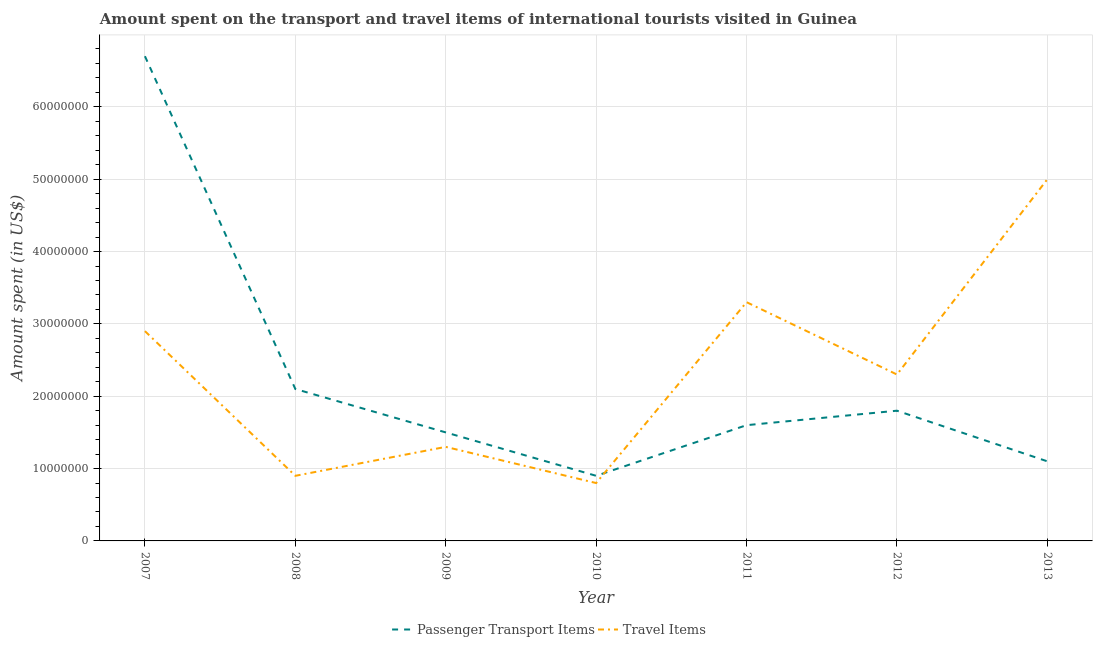How many different coloured lines are there?
Your response must be concise. 2. What is the amount spent on passenger transport items in 2008?
Your response must be concise. 2.10e+07. Across all years, what is the maximum amount spent in travel items?
Give a very brief answer. 5.00e+07. Across all years, what is the minimum amount spent on passenger transport items?
Offer a very short reply. 9.00e+06. In which year was the amount spent in travel items maximum?
Provide a short and direct response. 2013. What is the total amount spent on passenger transport items in the graph?
Make the answer very short. 1.57e+08. What is the difference between the amount spent on passenger transport items in 2008 and that in 2009?
Your answer should be very brief. 6.00e+06. What is the difference between the amount spent on passenger transport items in 2007 and the amount spent in travel items in 2011?
Give a very brief answer. 3.40e+07. What is the average amount spent on passenger transport items per year?
Provide a short and direct response. 2.24e+07. In the year 2009, what is the difference between the amount spent on passenger transport items and amount spent in travel items?
Your answer should be compact. 2.00e+06. In how many years, is the amount spent on passenger transport items greater than 28000000 US$?
Your answer should be compact. 1. What is the ratio of the amount spent in travel items in 2008 to that in 2011?
Offer a terse response. 0.27. Is the amount spent in travel items in 2009 less than that in 2010?
Offer a very short reply. No. Is the difference between the amount spent in travel items in 2010 and 2011 greater than the difference between the amount spent on passenger transport items in 2010 and 2011?
Give a very brief answer. No. What is the difference between the highest and the second highest amount spent on passenger transport items?
Your answer should be very brief. 4.60e+07. What is the difference between the highest and the lowest amount spent in travel items?
Provide a succinct answer. 4.20e+07. In how many years, is the amount spent on passenger transport items greater than the average amount spent on passenger transport items taken over all years?
Provide a succinct answer. 1. Is the sum of the amount spent in travel items in 2010 and 2012 greater than the maximum amount spent on passenger transport items across all years?
Keep it short and to the point. No. Is the amount spent in travel items strictly less than the amount spent on passenger transport items over the years?
Offer a terse response. No. How many lines are there?
Your answer should be very brief. 2. How many years are there in the graph?
Provide a succinct answer. 7. What is the difference between two consecutive major ticks on the Y-axis?
Give a very brief answer. 1.00e+07. Are the values on the major ticks of Y-axis written in scientific E-notation?
Ensure brevity in your answer.  No. Does the graph contain any zero values?
Offer a very short reply. No. Where does the legend appear in the graph?
Your answer should be compact. Bottom center. How many legend labels are there?
Provide a succinct answer. 2. What is the title of the graph?
Give a very brief answer. Amount spent on the transport and travel items of international tourists visited in Guinea. Does "Foreign Liabilities" appear as one of the legend labels in the graph?
Offer a terse response. No. What is the label or title of the Y-axis?
Keep it short and to the point. Amount spent (in US$). What is the Amount spent (in US$) in Passenger Transport Items in 2007?
Ensure brevity in your answer.  6.70e+07. What is the Amount spent (in US$) of Travel Items in 2007?
Offer a very short reply. 2.90e+07. What is the Amount spent (in US$) in Passenger Transport Items in 2008?
Provide a succinct answer. 2.10e+07. What is the Amount spent (in US$) in Travel Items in 2008?
Your answer should be compact. 9.00e+06. What is the Amount spent (in US$) of Passenger Transport Items in 2009?
Provide a succinct answer. 1.50e+07. What is the Amount spent (in US$) of Travel Items in 2009?
Your answer should be very brief. 1.30e+07. What is the Amount spent (in US$) of Passenger Transport Items in 2010?
Your response must be concise. 9.00e+06. What is the Amount spent (in US$) of Passenger Transport Items in 2011?
Your response must be concise. 1.60e+07. What is the Amount spent (in US$) in Travel Items in 2011?
Provide a short and direct response. 3.30e+07. What is the Amount spent (in US$) of Passenger Transport Items in 2012?
Your answer should be compact. 1.80e+07. What is the Amount spent (in US$) of Travel Items in 2012?
Your response must be concise. 2.30e+07. What is the Amount spent (in US$) of Passenger Transport Items in 2013?
Provide a succinct answer. 1.10e+07. What is the Amount spent (in US$) of Travel Items in 2013?
Make the answer very short. 5.00e+07. Across all years, what is the maximum Amount spent (in US$) of Passenger Transport Items?
Your response must be concise. 6.70e+07. Across all years, what is the minimum Amount spent (in US$) of Passenger Transport Items?
Provide a short and direct response. 9.00e+06. Across all years, what is the minimum Amount spent (in US$) in Travel Items?
Your answer should be compact. 8.00e+06. What is the total Amount spent (in US$) of Passenger Transport Items in the graph?
Offer a very short reply. 1.57e+08. What is the total Amount spent (in US$) of Travel Items in the graph?
Offer a terse response. 1.65e+08. What is the difference between the Amount spent (in US$) of Passenger Transport Items in 2007 and that in 2008?
Provide a succinct answer. 4.60e+07. What is the difference between the Amount spent (in US$) of Passenger Transport Items in 2007 and that in 2009?
Your answer should be compact. 5.20e+07. What is the difference between the Amount spent (in US$) in Travel Items in 2007 and that in 2009?
Make the answer very short. 1.60e+07. What is the difference between the Amount spent (in US$) in Passenger Transport Items in 2007 and that in 2010?
Offer a terse response. 5.80e+07. What is the difference between the Amount spent (in US$) in Travel Items in 2007 and that in 2010?
Your answer should be compact. 2.10e+07. What is the difference between the Amount spent (in US$) of Passenger Transport Items in 2007 and that in 2011?
Ensure brevity in your answer.  5.10e+07. What is the difference between the Amount spent (in US$) of Passenger Transport Items in 2007 and that in 2012?
Keep it short and to the point. 4.90e+07. What is the difference between the Amount spent (in US$) of Passenger Transport Items in 2007 and that in 2013?
Give a very brief answer. 5.60e+07. What is the difference between the Amount spent (in US$) in Travel Items in 2007 and that in 2013?
Provide a succinct answer. -2.10e+07. What is the difference between the Amount spent (in US$) in Passenger Transport Items in 2008 and that in 2011?
Make the answer very short. 5.00e+06. What is the difference between the Amount spent (in US$) of Travel Items in 2008 and that in 2011?
Your answer should be very brief. -2.40e+07. What is the difference between the Amount spent (in US$) of Travel Items in 2008 and that in 2012?
Your response must be concise. -1.40e+07. What is the difference between the Amount spent (in US$) in Passenger Transport Items in 2008 and that in 2013?
Your answer should be compact. 1.00e+07. What is the difference between the Amount spent (in US$) of Travel Items in 2008 and that in 2013?
Give a very brief answer. -4.10e+07. What is the difference between the Amount spent (in US$) of Travel Items in 2009 and that in 2011?
Provide a succinct answer. -2.00e+07. What is the difference between the Amount spent (in US$) of Passenger Transport Items in 2009 and that in 2012?
Make the answer very short. -3.00e+06. What is the difference between the Amount spent (in US$) in Travel Items in 2009 and that in 2012?
Your answer should be very brief. -1.00e+07. What is the difference between the Amount spent (in US$) in Travel Items in 2009 and that in 2013?
Give a very brief answer. -3.70e+07. What is the difference between the Amount spent (in US$) in Passenger Transport Items in 2010 and that in 2011?
Offer a terse response. -7.00e+06. What is the difference between the Amount spent (in US$) of Travel Items in 2010 and that in 2011?
Make the answer very short. -2.50e+07. What is the difference between the Amount spent (in US$) in Passenger Transport Items in 2010 and that in 2012?
Ensure brevity in your answer.  -9.00e+06. What is the difference between the Amount spent (in US$) in Travel Items in 2010 and that in 2012?
Your answer should be compact. -1.50e+07. What is the difference between the Amount spent (in US$) of Travel Items in 2010 and that in 2013?
Provide a succinct answer. -4.20e+07. What is the difference between the Amount spent (in US$) of Passenger Transport Items in 2011 and that in 2012?
Provide a succinct answer. -2.00e+06. What is the difference between the Amount spent (in US$) of Passenger Transport Items in 2011 and that in 2013?
Ensure brevity in your answer.  5.00e+06. What is the difference between the Amount spent (in US$) of Travel Items in 2011 and that in 2013?
Offer a terse response. -1.70e+07. What is the difference between the Amount spent (in US$) in Passenger Transport Items in 2012 and that in 2013?
Your answer should be very brief. 7.00e+06. What is the difference between the Amount spent (in US$) in Travel Items in 2012 and that in 2013?
Your answer should be compact. -2.70e+07. What is the difference between the Amount spent (in US$) of Passenger Transport Items in 2007 and the Amount spent (in US$) of Travel Items in 2008?
Offer a very short reply. 5.80e+07. What is the difference between the Amount spent (in US$) of Passenger Transport Items in 2007 and the Amount spent (in US$) of Travel Items in 2009?
Your response must be concise. 5.40e+07. What is the difference between the Amount spent (in US$) of Passenger Transport Items in 2007 and the Amount spent (in US$) of Travel Items in 2010?
Make the answer very short. 5.90e+07. What is the difference between the Amount spent (in US$) in Passenger Transport Items in 2007 and the Amount spent (in US$) in Travel Items in 2011?
Your answer should be very brief. 3.40e+07. What is the difference between the Amount spent (in US$) of Passenger Transport Items in 2007 and the Amount spent (in US$) of Travel Items in 2012?
Ensure brevity in your answer.  4.40e+07. What is the difference between the Amount spent (in US$) in Passenger Transport Items in 2007 and the Amount spent (in US$) in Travel Items in 2013?
Your answer should be very brief. 1.70e+07. What is the difference between the Amount spent (in US$) of Passenger Transport Items in 2008 and the Amount spent (in US$) of Travel Items in 2009?
Offer a terse response. 8.00e+06. What is the difference between the Amount spent (in US$) in Passenger Transport Items in 2008 and the Amount spent (in US$) in Travel Items in 2010?
Make the answer very short. 1.30e+07. What is the difference between the Amount spent (in US$) in Passenger Transport Items in 2008 and the Amount spent (in US$) in Travel Items in 2011?
Provide a short and direct response. -1.20e+07. What is the difference between the Amount spent (in US$) of Passenger Transport Items in 2008 and the Amount spent (in US$) of Travel Items in 2012?
Offer a terse response. -2.00e+06. What is the difference between the Amount spent (in US$) in Passenger Transport Items in 2008 and the Amount spent (in US$) in Travel Items in 2013?
Offer a terse response. -2.90e+07. What is the difference between the Amount spent (in US$) in Passenger Transport Items in 2009 and the Amount spent (in US$) in Travel Items in 2010?
Offer a very short reply. 7.00e+06. What is the difference between the Amount spent (in US$) in Passenger Transport Items in 2009 and the Amount spent (in US$) in Travel Items in 2011?
Your answer should be compact. -1.80e+07. What is the difference between the Amount spent (in US$) in Passenger Transport Items in 2009 and the Amount spent (in US$) in Travel Items in 2012?
Offer a terse response. -8.00e+06. What is the difference between the Amount spent (in US$) of Passenger Transport Items in 2009 and the Amount spent (in US$) of Travel Items in 2013?
Provide a succinct answer. -3.50e+07. What is the difference between the Amount spent (in US$) of Passenger Transport Items in 2010 and the Amount spent (in US$) of Travel Items in 2011?
Ensure brevity in your answer.  -2.40e+07. What is the difference between the Amount spent (in US$) of Passenger Transport Items in 2010 and the Amount spent (in US$) of Travel Items in 2012?
Keep it short and to the point. -1.40e+07. What is the difference between the Amount spent (in US$) of Passenger Transport Items in 2010 and the Amount spent (in US$) of Travel Items in 2013?
Provide a succinct answer. -4.10e+07. What is the difference between the Amount spent (in US$) in Passenger Transport Items in 2011 and the Amount spent (in US$) in Travel Items in 2012?
Offer a very short reply. -7.00e+06. What is the difference between the Amount spent (in US$) of Passenger Transport Items in 2011 and the Amount spent (in US$) of Travel Items in 2013?
Your answer should be very brief. -3.40e+07. What is the difference between the Amount spent (in US$) of Passenger Transport Items in 2012 and the Amount spent (in US$) of Travel Items in 2013?
Your answer should be compact. -3.20e+07. What is the average Amount spent (in US$) of Passenger Transport Items per year?
Your answer should be compact. 2.24e+07. What is the average Amount spent (in US$) in Travel Items per year?
Offer a very short reply. 2.36e+07. In the year 2007, what is the difference between the Amount spent (in US$) in Passenger Transport Items and Amount spent (in US$) in Travel Items?
Offer a very short reply. 3.80e+07. In the year 2010, what is the difference between the Amount spent (in US$) in Passenger Transport Items and Amount spent (in US$) in Travel Items?
Give a very brief answer. 1.00e+06. In the year 2011, what is the difference between the Amount spent (in US$) in Passenger Transport Items and Amount spent (in US$) in Travel Items?
Your answer should be very brief. -1.70e+07. In the year 2012, what is the difference between the Amount spent (in US$) of Passenger Transport Items and Amount spent (in US$) of Travel Items?
Keep it short and to the point. -5.00e+06. In the year 2013, what is the difference between the Amount spent (in US$) in Passenger Transport Items and Amount spent (in US$) in Travel Items?
Make the answer very short. -3.90e+07. What is the ratio of the Amount spent (in US$) of Passenger Transport Items in 2007 to that in 2008?
Offer a terse response. 3.19. What is the ratio of the Amount spent (in US$) in Travel Items in 2007 to that in 2008?
Make the answer very short. 3.22. What is the ratio of the Amount spent (in US$) in Passenger Transport Items in 2007 to that in 2009?
Your answer should be compact. 4.47. What is the ratio of the Amount spent (in US$) in Travel Items in 2007 to that in 2009?
Your answer should be very brief. 2.23. What is the ratio of the Amount spent (in US$) in Passenger Transport Items in 2007 to that in 2010?
Your response must be concise. 7.44. What is the ratio of the Amount spent (in US$) in Travel Items in 2007 to that in 2010?
Keep it short and to the point. 3.62. What is the ratio of the Amount spent (in US$) of Passenger Transport Items in 2007 to that in 2011?
Keep it short and to the point. 4.19. What is the ratio of the Amount spent (in US$) in Travel Items in 2007 to that in 2011?
Provide a short and direct response. 0.88. What is the ratio of the Amount spent (in US$) of Passenger Transport Items in 2007 to that in 2012?
Ensure brevity in your answer.  3.72. What is the ratio of the Amount spent (in US$) of Travel Items in 2007 to that in 2012?
Your answer should be compact. 1.26. What is the ratio of the Amount spent (in US$) in Passenger Transport Items in 2007 to that in 2013?
Ensure brevity in your answer.  6.09. What is the ratio of the Amount spent (in US$) in Travel Items in 2007 to that in 2013?
Your answer should be very brief. 0.58. What is the ratio of the Amount spent (in US$) of Passenger Transport Items in 2008 to that in 2009?
Give a very brief answer. 1.4. What is the ratio of the Amount spent (in US$) of Travel Items in 2008 to that in 2009?
Your answer should be very brief. 0.69. What is the ratio of the Amount spent (in US$) in Passenger Transport Items in 2008 to that in 2010?
Offer a terse response. 2.33. What is the ratio of the Amount spent (in US$) in Passenger Transport Items in 2008 to that in 2011?
Give a very brief answer. 1.31. What is the ratio of the Amount spent (in US$) in Travel Items in 2008 to that in 2011?
Your answer should be compact. 0.27. What is the ratio of the Amount spent (in US$) of Passenger Transport Items in 2008 to that in 2012?
Give a very brief answer. 1.17. What is the ratio of the Amount spent (in US$) of Travel Items in 2008 to that in 2012?
Keep it short and to the point. 0.39. What is the ratio of the Amount spent (in US$) of Passenger Transport Items in 2008 to that in 2013?
Keep it short and to the point. 1.91. What is the ratio of the Amount spent (in US$) of Travel Items in 2008 to that in 2013?
Your response must be concise. 0.18. What is the ratio of the Amount spent (in US$) of Travel Items in 2009 to that in 2010?
Provide a short and direct response. 1.62. What is the ratio of the Amount spent (in US$) of Travel Items in 2009 to that in 2011?
Offer a very short reply. 0.39. What is the ratio of the Amount spent (in US$) in Passenger Transport Items in 2009 to that in 2012?
Offer a very short reply. 0.83. What is the ratio of the Amount spent (in US$) of Travel Items in 2009 to that in 2012?
Keep it short and to the point. 0.57. What is the ratio of the Amount spent (in US$) in Passenger Transport Items in 2009 to that in 2013?
Ensure brevity in your answer.  1.36. What is the ratio of the Amount spent (in US$) in Travel Items in 2009 to that in 2013?
Make the answer very short. 0.26. What is the ratio of the Amount spent (in US$) of Passenger Transport Items in 2010 to that in 2011?
Make the answer very short. 0.56. What is the ratio of the Amount spent (in US$) of Travel Items in 2010 to that in 2011?
Provide a succinct answer. 0.24. What is the ratio of the Amount spent (in US$) in Passenger Transport Items in 2010 to that in 2012?
Keep it short and to the point. 0.5. What is the ratio of the Amount spent (in US$) in Travel Items in 2010 to that in 2012?
Make the answer very short. 0.35. What is the ratio of the Amount spent (in US$) of Passenger Transport Items in 2010 to that in 2013?
Offer a very short reply. 0.82. What is the ratio of the Amount spent (in US$) in Travel Items in 2010 to that in 2013?
Your response must be concise. 0.16. What is the ratio of the Amount spent (in US$) of Passenger Transport Items in 2011 to that in 2012?
Your response must be concise. 0.89. What is the ratio of the Amount spent (in US$) in Travel Items in 2011 to that in 2012?
Keep it short and to the point. 1.43. What is the ratio of the Amount spent (in US$) in Passenger Transport Items in 2011 to that in 2013?
Provide a short and direct response. 1.45. What is the ratio of the Amount spent (in US$) of Travel Items in 2011 to that in 2013?
Give a very brief answer. 0.66. What is the ratio of the Amount spent (in US$) in Passenger Transport Items in 2012 to that in 2013?
Your answer should be compact. 1.64. What is the ratio of the Amount spent (in US$) of Travel Items in 2012 to that in 2013?
Your answer should be compact. 0.46. What is the difference between the highest and the second highest Amount spent (in US$) of Passenger Transport Items?
Offer a terse response. 4.60e+07. What is the difference between the highest and the second highest Amount spent (in US$) of Travel Items?
Your answer should be compact. 1.70e+07. What is the difference between the highest and the lowest Amount spent (in US$) in Passenger Transport Items?
Ensure brevity in your answer.  5.80e+07. What is the difference between the highest and the lowest Amount spent (in US$) of Travel Items?
Offer a very short reply. 4.20e+07. 